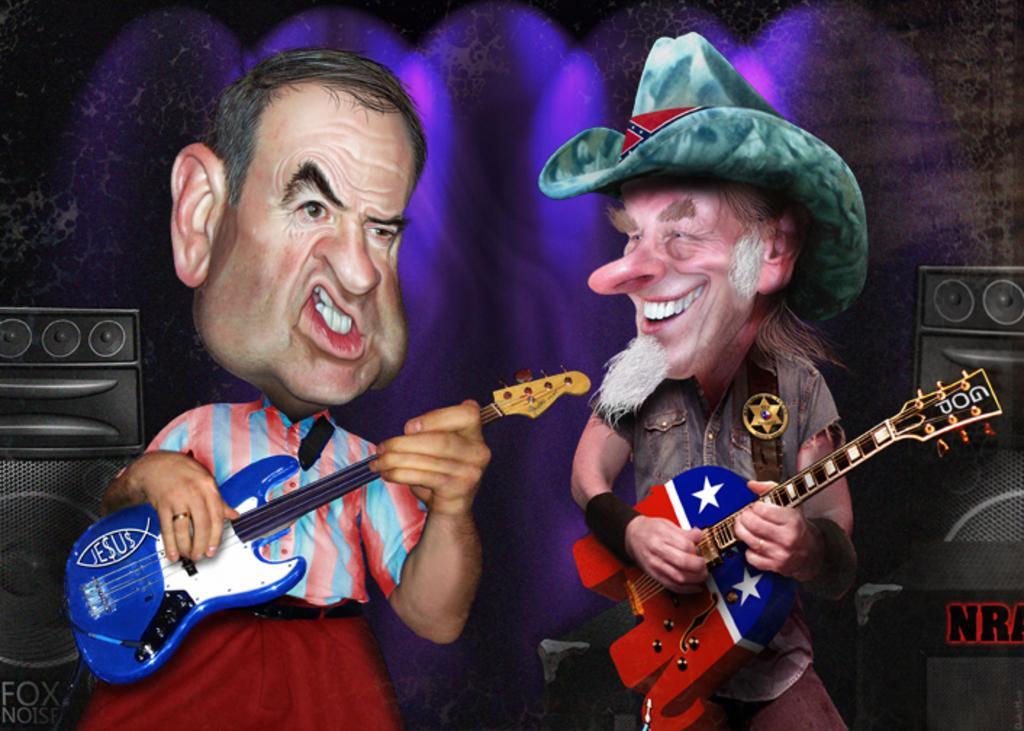Can you describe this image briefly? +In this image there are two cartoon characters. They both are playing guitar. In the right the cartoon is wearing hat he is smiling. There are speakers in both sides. In the background there are lights. 